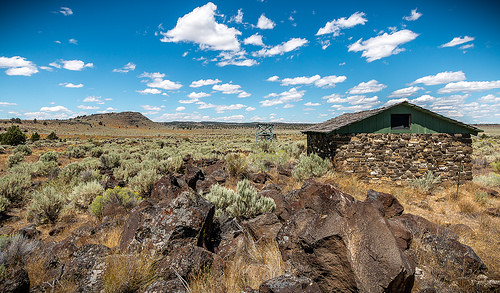<image>
Is the bush in front of the building? No. The bush is not in front of the building. The spatial positioning shows a different relationship between these objects. 